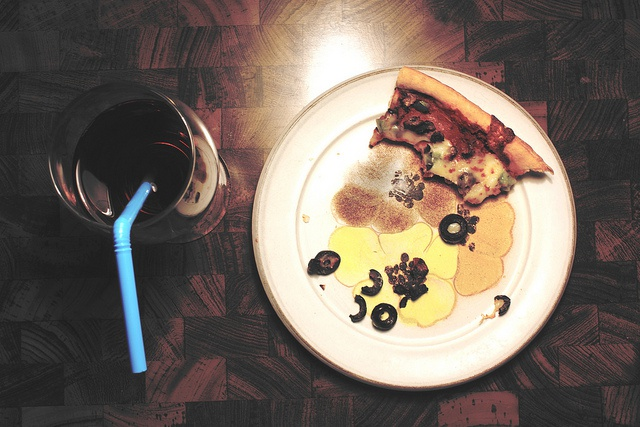Describe the objects in this image and their specific colors. I can see dining table in black, ivory, brown, and khaki tones, cup in black, brown, and tan tones, and pizza in black, tan, brown, and maroon tones in this image. 